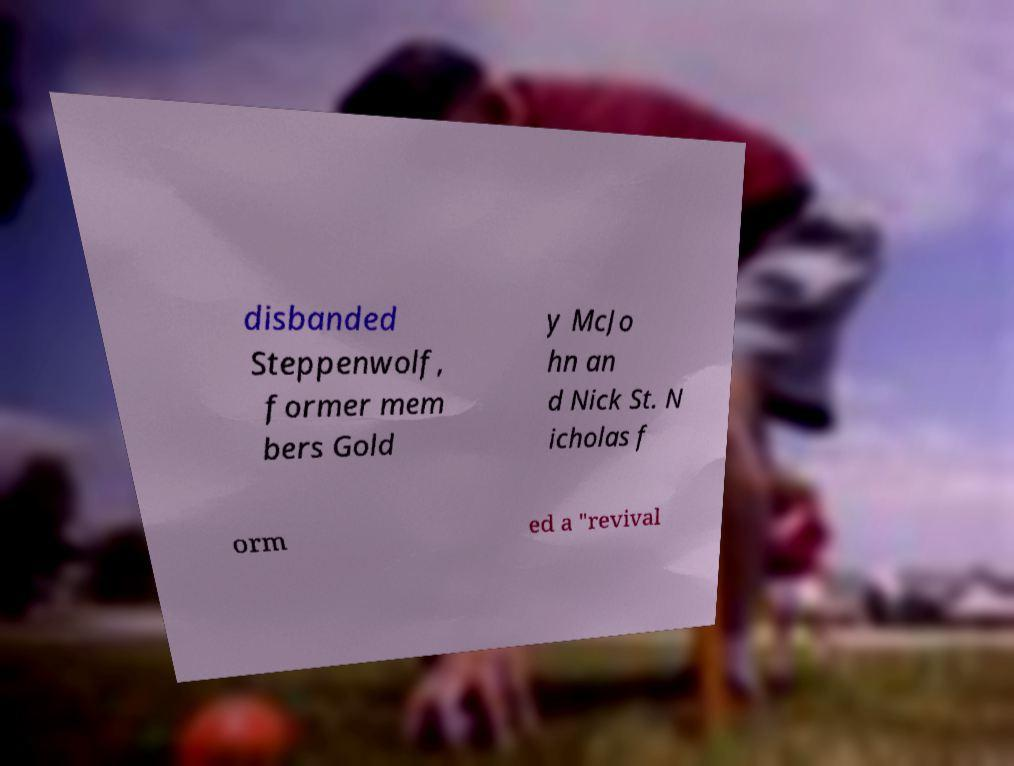I need the written content from this picture converted into text. Can you do that? disbanded Steppenwolf, former mem bers Gold y McJo hn an d Nick St. N icholas f orm ed a "revival 